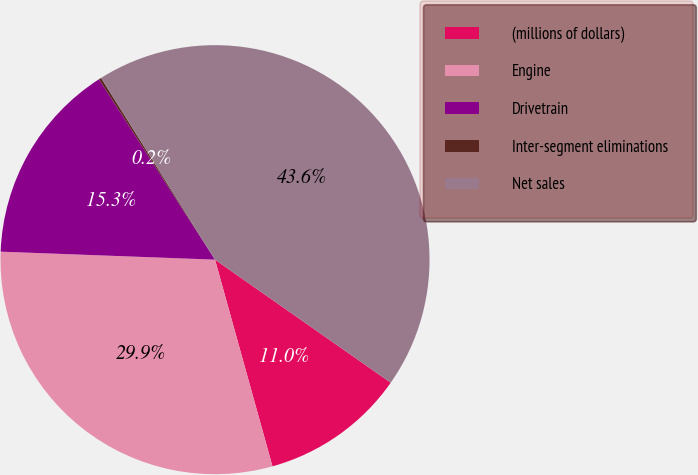<chart> <loc_0><loc_0><loc_500><loc_500><pie_chart><fcel>(millions of dollars)<fcel>Engine<fcel>Drivetrain<fcel>Inter-segment eliminations<fcel>Net sales<nl><fcel>10.96%<fcel>29.91%<fcel>15.31%<fcel>0.18%<fcel>43.64%<nl></chart> 